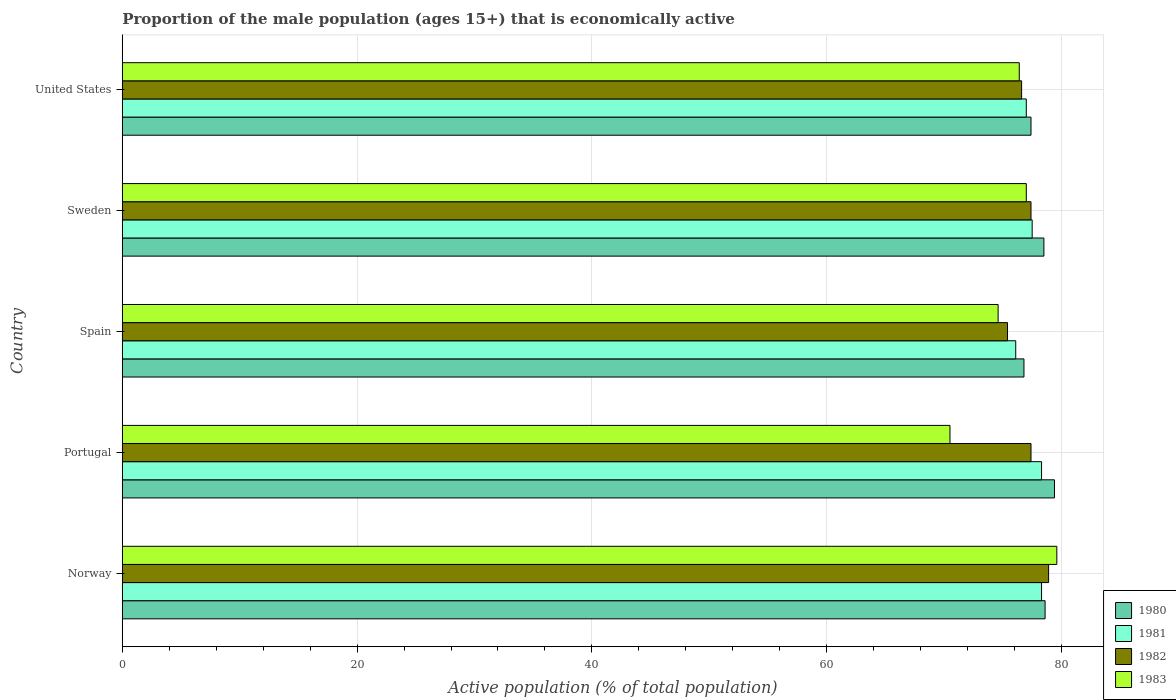How many groups of bars are there?
Your answer should be compact. 5. Are the number of bars on each tick of the Y-axis equal?
Make the answer very short. Yes. How many bars are there on the 3rd tick from the top?
Keep it short and to the point. 4. In how many cases, is the number of bars for a given country not equal to the number of legend labels?
Offer a very short reply. 0. What is the proportion of the male population that is economically active in 1982 in United States?
Give a very brief answer. 76.6. Across all countries, what is the maximum proportion of the male population that is economically active in 1980?
Give a very brief answer. 79.4. Across all countries, what is the minimum proportion of the male population that is economically active in 1980?
Your answer should be compact. 76.8. In which country was the proportion of the male population that is economically active in 1983 maximum?
Ensure brevity in your answer.  Norway. In which country was the proportion of the male population that is economically active in 1981 minimum?
Your answer should be compact. Spain. What is the total proportion of the male population that is economically active in 1983 in the graph?
Offer a terse response. 378.1. What is the difference between the proportion of the male population that is economically active in 1982 in Portugal and that in United States?
Your answer should be compact. 0.8. What is the difference between the proportion of the male population that is economically active in 1982 in Portugal and the proportion of the male population that is economically active in 1980 in Norway?
Your answer should be compact. -1.2. What is the average proportion of the male population that is economically active in 1981 per country?
Provide a succinct answer. 77.44. What is the difference between the proportion of the male population that is economically active in 1981 and proportion of the male population that is economically active in 1983 in Portugal?
Make the answer very short. 7.8. What is the ratio of the proportion of the male population that is economically active in 1980 in Norway to that in Spain?
Offer a very short reply. 1.02. Is the difference between the proportion of the male population that is economically active in 1981 in Portugal and Sweden greater than the difference between the proportion of the male population that is economically active in 1983 in Portugal and Sweden?
Offer a terse response. Yes. What is the difference between the highest and the second highest proportion of the male population that is economically active in 1983?
Offer a very short reply. 2.6. What is the difference between the highest and the lowest proportion of the male population that is economically active in 1980?
Keep it short and to the point. 2.6. In how many countries, is the proportion of the male population that is economically active in 1980 greater than the average proportion of the male population that is economically active in 1980 taken over all countries?
Your answer should be compact. 3. Is the sum of the proportion of the male population that is economically active in 1980 in Norway and Sweden greater than the maximum proportion of the male population that is economically active in 1983 across all countries?
Offer a very short reply. Yes. What does the 1st bar from the top in Sweden represents?
Provide a short and direct response. 1983. What does the 2nd bar from the bottom in United States represents?
Provide a short and direct response. 1981. How many bars are there?
Keep it short and to the point. 20. How many countries are there in the graph?
Ensure brevity in your answer.  5. Does the graph contain grids?
Make the answer very short. Yes. Where does the legend appear in the graph?
Offer a terse response. Bottom right. How are the legend labels stacked?
Ensure brevity in your answer.  Vertical. What is the title of the graph?
Offer a terse response. Proportion of the male population (ages 15+) that is economically active. Does "2010" appear as one of the legend labels in the graph?
Keep it short and to the point. No. What is the label or title of the X-axis?
Ensure brevity in your answer.  Active population (% of total population). What is the label or title of the Y-axis?
Offer a very short reply. Country. What is the Active population (% of total population) of 1980 in Norway?
Ensure brevity in your answer.  78.6. What is the Active population (% of total population) in 1981 in Norway?
Give a very brief answer. 78.3. What is the Active population (% of total population) of 1982 in Norway?
Your answer should be very brief. 78.9. What is the Active population (% of total population) of 1983 in Norway?
Provide a succinct answer. 79.6. What is the Active population (% of total population) of 1980 in Portugal?
Give a very brief answer. 79.4. What is the Active population (% of total population) of 1981 in Portugal?
Make the answer very short. 78.3. What is the Active population (% of total population) of 1982 in Portugal?
Ensure brevity in your answer.  77.4. What is the Active population (% of total population) of 1983 in Portugal?
Provide a succinct answer. 70.5. What is the Active population (% of total population) in 1980 in Spain?
Your answer should be very brief. 76.8. What is the Active population (% of total population) of 1981 in Spain?
Give a very brief answer. 76.1. What is the Active population (% of total population) in 1982 in Spain?
Offer a very short reply. 75.4. What is the Active population (% of total population) in 1983 in Spain?
Your answer should be compact. 74.6. What is the Active population (% of total population) in 1980 in Sweden?
Provide a succinct answer. 78.5. What is the Active population (% of total population) of 1981 in Sweden?
Keep it short and to the point. 77.5. What is the Active population (% of total population) of 1982 in Sweden?
Give a very brief answer. 77.4. What is the Active population (% of total population) in 1983 in Sweden?
Ensure brevity in your answer.  77. What is the Active population (% of total population) in 1980 in United States?
Your answer should be compact. 77.4. What is the Active population (% of total population) of 1982 in United States?
Provide a succinct answer. 76.6. What is the Active population (% of total population) in 1983 in United States?
Keep it short and to the point. 76.4. Across all countries, what is the maximum Active population (% of total population) in 1980?
Ensure brevity in your answer.  79.4. Across all countries, what is the maximum Active population (% of total population) in 1981?
Your answer should be very brief. 78.3. Across all countries, what is the maximum Active population (% of total population) in 1982?
Your answer should be very brief. 78.9. Across all countries, what is the maximum Active population (% of total population) of 1983?
Your answer should be compact. 79.6. Across all countries, what is the minimum Active population (% of total population) of 1980?
Your answer should be very brief. 76.8. Across all countries, what is the minimum Active population (% of total population) of 1981?
Your answer should be compact. 76.1. Across all countries, what is the minimum Active population (% of total population) in 1982?
Provide a short and direct response. 75.4. Across all countries, what is the minimum Active population (% of total population) in 1983?
Keep it short and to the point. 70.5. What is the total Active population (% of total population) in 1980 in the graph?
Provide a succinct answer. 390.7. What is the total Active population (% of total population) of 1981 in the graph?
Provide a succinct answer. 387.2. What is the total Active population (% of total population) in 1982 in the graph?
Give a very brief answer. 385.7. What is the total Active population (% of total population) of 1983 in the graph?
Provide a short and direct response. 378.1. What is the difference between the Active population (% of total population) of 1982 in Norway and that in Portugal?
Keep it short and to the point. 1.5. What is the difference between the Active population (% of total population) in 1980 in Norway and that in Spain?
Make the answer very short. 1.8. What is the difference between the Active population (% of total population) in 1982 in Norway and that in Spain?
Keep it short and to the point. 3.5. What is the difference between the Active population (% of total population) of 1980 in Norway and that in Sweden?
Your answer should be very brief. 0.1. What is the difference between the Active population (% of total population) of 1981 in Norway and that in Sweden?
Make the answer very short. 0.8. What is the difference between the Active population (% of total population) of 1982 in Norway and that in Sweden?
Make the answer very short. 1.5. What is the difference between the Active population (% of total population) in 1983 in Norway and that in Sweden?
Keep it short and to the point. 2.6. What is the difference between the Active population (% of total population) of 1980 in Norway and that in United States?
Make the answer very short. 1.2. What is the difference between the Active population (% of total population) in 1982 in Norway and that in United States?
Ensure brevity in your answer.  2.3. What is the difference between the Active population (% of total population) of 1980 in Portugal and that in Spain?
Your response must be concise. 2.6. What is the difference between the Active population (% of total population) of 1981 in Portugal and that in Spain?
Offer a very short reply. 2.2. What is the difference between the Active population (% of total population) of 1982 in Portugal and that in Spain?
Provide a short and direct response. 2. What is the difference between the Active population (% of total population) of 1983 in Portugal and that in Spain?
Your answer should be very brief. -4.1. What is the difference between the Active population (% of total population) in 1981 in Portugal and that in Sweden?
Your answer should be compact. 0.8. What is the difference between the Active population (% of total population) in 1982 in Portugal and that in Sweden?
Provide a short and direct response. 0. What is the difference between the Active population (% of total population) of 1983 in Portugal and that in Sweden?
Your response must be concise. -6.5. What is the difference between the Active population (% of total population) of 1981 in Portugal and that in United States?
Your answer should be very brief. 1.3. What is the difference between the Active population (% of total population) in 1982 in Portugal and that in United States?
Offer a terse response. 0.8. What is the difference between the Active population (% of total population) of 1981 in Spain and that in Sweden?
Provide a short and direct response. -1.4. What is the difference between the Active population (% of total population) of 1982 in Spain and that in Sweden?
Keep it short and to the point. -2. What is the difference between the Active population (% of total population) of 1980 in Spain and that in United States?
Provide a short and direct response. -0.6. What is the difference between the Active population (% of total population) in 1981 in Spain and that in United States?
Your answer should be very brief. -0.9. What is the difference between the Active population (% of total population) in 1982 in Sweden and that in United States?
Ensure brevity in your answer.  0.8. What is the difference between the Active population (% of total population) of 1980 in Norway and the Active population (% of total population) of 1981 in Portugal?
Your answer should be very brief. 0.3. What is the difference between the Active population (% of total population) of 1980 in Norway and the Active population (% of total population) of 1982 in Portugal?
Ensure brevity in your answer.  1.2. What is the difference between the Active population (% of total population) in 1980 in Norway and the Active population (% of total population) in 1983 in Portugal?
Offer a very short reply. 8.1. What is the difference between the Active population (% of total population) in 1980 in Norway and the Active population (% of total population) in 1983 in Spain?
Your response must be concise. 4. What is the difference between the Active population (% of total population) of 1981 in Norway and the Active population (% of total population) of 1982 in Spain?
Provide a short and direct response. 2.9. What is the difference between the Active population (% of total population) of 1981 in Norway and the Active population (% of total population) of 1983 in Spain?
Offer a very short reply. 3.7. What is the difference between the Active population (% of total population) of 1980 in Norway and the Active population (% of total population) of 1983 in Sweden?
Your answer should be very brief. 1.6. What is the difference between the Active population (% of total population) in 1981 in Norway and the Active population (% of total population) in 1982 in Sweden?
Give a very brief answer. 0.9. What is the difference between the Active population (% of total population) of 1982 in Norway and the Active population (% of total population) of 1983 in Sweden?
Offer a terse response. 1.9. What is the difference between the Active population (% of total population) of 1980 in Norway and the Active population (% of total population) of 1983 in United States?
Make the answer very short. 2.2. What is the difference between the Active population (% of total population) in 1981 in Norway and the Active population (% of total population) in 1983 in United States?
Offer a terse response. 1.9. What is the difference between the Active population (% of total population) in 1982 in Norway and the Active population (% of total population) in 1983 in United States?
Your answer should be compact. 2.5. What is the difference between the Active population (% of total population) of 1980 in Portugal and the Active population (% of total population) of 1981 in Spain?
Your response must be concise. 3.3. What is the difference between the Active population (% of total population) in 1980 in Portugal and the Active population (% of total population) in 1983 in Spain?
Make the answer very short. 4.8. What is the difference between the Active population (% of total population) in 1980 in Portugal and the Active population (% of total population) in 1982 in Sweden?
Offer a terse response. 2. What is the difference between the Active population (% of total population) in 1980 in Portugal and the Active population (% of total population) in 1983 in Sweden?
Keep it short and to the point. 2.4. What is the difference between the Active population (% of total population) of 1981 in Portugal and the Active population (% of total population) of 1982 in Sweden?
Make the answer very short. 0.9. What is the difference between the Active population (% of total population) of 1981 in Portugal and the Active population (% of total population) of 1983 in Sweden?
Keep it short and to the point. 1.3. What is the difference between the Active population (% of total population) of 1980 in Spain and the Active population (% of total population) of 1981 in Sweden?
Offer a very short reply. -0.7. What is the difference between the Active population (% of total population) in 1981 in Spain and the Active population (% of total population) in 1982 in Sweden?
Make the answer very short. -1.3. What is the difference between the Active population (% of total population) in 1981 in Spain and the Active population (% of total population) in 1983 in Sweden?
Make the answer very short. -0.9. What is the difference between the Active population (% of total population) of 1980 in Spain and the Active population (% of total population) of 1982 in United States?
Give a very brief answer. 0.2. What is the difference between the Active population (% of total population) in 1980 in Spain and the Active population (% of total population) in 1983 in United States?
Ensure brevity in your answer.  0.4. What is the difference between the Active population (% of total population) in 1981 in Spain and the Active population (% of total population) in 1983 in United States?
Offer a very short reply. -0.3. What is the difference between the Active population (% of total population) of 1982 in Spain and the Active population (% of total population) of 1983 in United States?
Provide a short and direct response. -1. What is the difference between the Active population (% of total population) in 1980 in Sweden and the Active population (% of total population) in 1982 in United States?
Offer a terse response. 1.9. What is the difference between the Active population (% of total population) of 1980 in Sweden and the Active population (% of total population) of 1983 in United States?
Offer a very short reply. 2.1. What is the difference between the Active population (% of total population) of 1981 in Sweden and the Active population (% of total population) of 1982 in United States?
Make the answer very short. 0.9. What is the difference between the Active population (% of total population) of 1981 in Sweden and the Active population (% of total population) of 1983 in United States?
Provide a short and direct response. 1.1. What is the difference between the Active population (% of total population) of 1982 in Sweden and the Active population (% of total population) of 1983 in United States?
Keep it short and to the point. 1. What is the average Active population (% of total population) of 1980 per country?
Your answer should be very brief. 78.14. What is the average Active population (% of total population) in 1981 per country?
Offer a terse response. 77.44. What is the average Active population (% of total population) of 1982 per country?
Your answer should be compact. 77.14. What is the average Active population (% of total population) of 1983 per country?
Give a very brief answer. 75.62. What is the difference between the Active population (% of total population) of 1980 and Active population (% of total population) of 1982 in Norway?
Offer a terse response. -0.3. What is the difference between the Active population (% of total population) of 1980 and Active population (% of total population) of 1983 in Norway?
Your response must be concise. -1. What is the difference between the Active population (% of total population) of 1981 and Active population (% of total population) of 1982 in Norway?
Provide a succinct answer. -0.6. What is the difference between the Active population (% of total population) of 1980 and Active population (% of total population) of 1982 in Portugal?
Provide a short and direct response. 2. What is the difference between the Active population (% of total population) in 1982 and Active population (% of total population) in 1983 in Portugal?
Provide a succinct answer. 6.9. What is the difference between the Active population (% of total population) of 1980 and Active population (% of total population) of 1983 in Spain?
Your answer should be compact. 2.2. What is the difference between the Active population (% of total population) in 1981 and Active population (% of total population) in 1982 in Spain?
Give a very brief answer. 0.7. What is the difference between the Active population (% of total population) of 1981 and Active population (% of total population) of 1983 in Spain?
Give a very brief answer. 1.5. What is the difference between the Active population (% of total population) of 1980 and Active population (% of total population) of 1981 in Sweden?
Offer a terse response. 1. What is the difference between the Active population (% of total population) in 1980 and Active population (% of total population) in 1983 in Sweden?
Give a very brief answer. 1.5. What is the difference between the Active population (% of total population) in 1981 and Active population (% of total population) in 1982 in Sweden?
Make the answer very short. 0.1. What is the difference between the Active population (% of total population) of 1981 and Active population (% of total population) of 1983 in Sweden?
Ensure brevity in your answer.  0.5. What is the difference between the Active population (% of total population) in 1980 and Active population (% of total population) in 1981 in United States?
Offer a terse response. 0.4. What is the difference between the Active population (% of total population) in 1981 and Active population (% of total population) in 1983 in United States?
Offer a very short reply. 0.6. What is the difference between the Active population (% of total population) of 1982 and Active population (% of total population) of 1983 in United States?
Your response must be concise. 0.2. What is the ratio of the Active population (% of total population) in 1980 in Norway to that in Portugal?
Provide a succinct answer. 0.99. What is the ratio of the Active population (% of total population) of 1981 in Norway to that in Portugal?
Ensure brevity in your answer.  1. What is the ratio of the Active population (% of total population) of 1982 in Norway to that in Portugal?
Your response must be concise. 1.02. What is the ratio of the Active population (% of total population) in 1983 in Norway to that in Portugal?
Your response must be concise. 1.13. What is the ratio of the Active population (% of total population) in 1980 in Norway to that in Spain?
Keep it short and to the point. 1.02. What is the ratio of the Active population (% of total population) in 1981 in Norway to that in Spain?
Your answer should be very brief. 1.03. What is the ratio of the Active population (% of total population) of 1982 in Norway to that in Spain?
Ensure brevity in your answer.  1.05. What is the ratio of the Active population (% of total population) in 1983 in Norway to that in Spain?
Give a very brief answer. 1.07. What is the ratio of the Active population (% of total population) in 1980 in Norway to that in Sweden?
Your answer should be very brief. 1. What is the ratio of the Active population (% of total population) of 1981 in Norway to that in Sweden?
Provide a short and direct response. 1.01. What is the ratio of the Active population (% of total population) in 1982 in Norway to that in Sweden?
Offer a very short reply. 1.02. What is the ratio of the Active population (% of total population) in 1983 in Norway to that in Sweden?
Keep it short and to the point. 1.03. What is the ratio of the Active population (% of total population) in 1980 in Norway to that in United States?
Offer a very short reply. 1.02. What is the ratio of the Active population (% of total population) in 1981 in Norway to that in United States?
Your response must be concise. 1.02. What is the ratio of the Active population (% of total population) of 1982 in Norway to that in United States?
Make the answer very short. 1.03. What is the ratio of the Active population (% of total population) in 1983 in Norway to that in United States?
Make the answer very short. 1.04. What is the ratio of the Active population (% of total population) of 1980 in Portugal to that in Spain?
Ensure brevity in your answer.  1.03. What is the ratio of the Active population (% of total population) in 1981 in Portugal to that in Spain?
Ensure brevity in your answer.  1.03. What is the ratio of the Active population (% of total population) of 1982 in Portugal to that in Spain?
Your answer should be very brief. 1.03. What is the ratio of the Active population (% of total population) in 1983 in Portugal to that in Spain?
Make the answer very short. 0.94. What is the ratio of the Active population (% of total population) in 1980 in Portugal to that in Sweden?
Make the answer very short. 1.01. What is the ratio of the Active population (% of total population) in 1981 in Portugal to that in Sweden?
Your answer should be compact. 1.01. What is the ratio of the Active population (% of total population) of 1982 in Portugal to that in Sweden?
Give a very brief answer. 1. What is the ratio of the Active population (% of total population) of 1983 in Portugal to that in Sweden?
Provide a succinct answer. 0.92. What is the ratio of the Active population (% of total population) in 1980 in Portugal to that in United States?
Offer a terse response. 1.03. What is the ratio of the Active population (% of total population) in 1981 in Portugal to that in United States?
Offer a very short reply. 1.02. What is the ratio of the Active population (% of total population) of 1982 in Portugal to that in United States?
Your answer should be very brief. 1.01. What is the ratio of the Active population (% of total population) of 1983 in Portugal to that in United States?
Your answer should be very brief. 0.92. What is the ratio of the Active population (% of total population) in 1980 in Spain to that in Sweden?
Offer a very short reply. 0.98. What is the ratio of the Active population (% of total population) in 1981 in Spain to that in Sweden?
Your answer should be very brief. 0.98. What is the ratio of the Active population (% of total population) of 1982 in Spain to that in Sweden?
Your response must be concise. 0.97. What is the ratio of the Active population (% of total population) in 1983 in Spain to that in Sweden?
Make the answer very short. 0.97. What is the ratio of the Active population (% of total population) of 1980 in Spain to that in United States?
Provide a succinct answer. 0.99. What is the ratio of the Active population (% of total population) in 1981 in Spain to that in United States?
Ensure brevity in your answer.  0.99. What is the ratio of the Active population (% of total population) of 1982 in Spain to that in United States?
Make the answer very short. 0.98. What is the ratio of the Active population (% of total population) of 1983 in Spain to that in United States?
Your answer should be very brief. 0.98. What is the ratio of the Active population (% of total population) in 1980 in Sweden to that in United States?
Your response must be concise. 1.01. What is the ratio of the Active population (% of total population) in 1982 in Sweden to that in United States?
Provide a short and direct response. 1.01. What is the ratio of the Active population (% of total population) in 1983 in Sweden to that in United States?
Make the answer very short. 1.01. What is the difference between the highest and the second highest Active population (% of total population) of 1981?
Keep it short and to the point. 0. What is the difference between the highest and the second highest Active population (% of total population) of 1983?
Make the answer very short. 2.6. What is the difference between the highest and the lowest Active population (% of total population) in 1980?
Offer a terse response. 2.6. What is the difference between the highest and the lowest Active population (% of total population) in 1982?
Your answer should be compact. 3.5. 